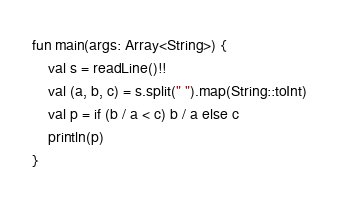Convert code to text. <code><loc_0><loc_0><loc_500><loc_500><_Kotlin_>fun main(args: Array<String>) {
    val s = readLine()!!
    val (a, b, c) = s.split(" ").map(String::toInt)
    val p = if (b / a < c) b / a else c
    println(p)
}</code> 